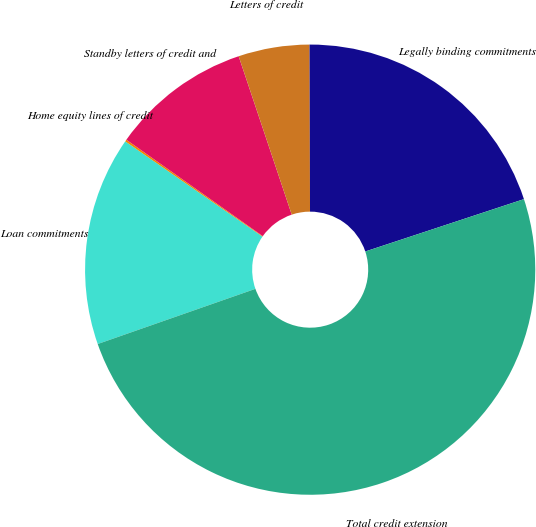Convert chart to OTSL. <chart><loc_0><loc_0><loc_500><loc_500><pie_chart><fcel>Loan commitments<fcel>Home equity lines of credit<fcel>Standby letters of credit and<fcel>Letters of credit<fcel>Legally binding commitments<fcel>Total credit extension<nl><fcel>15.01%<fcel>0.14%<fcel>10.06%<fcel>5.1%<fcel>19.97%<fcel>49.71%<nl></chart> 